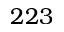Convert formula to latex. <formula><loc_0><loc_0><loc_500><loc_500>2 2 3</formula> 